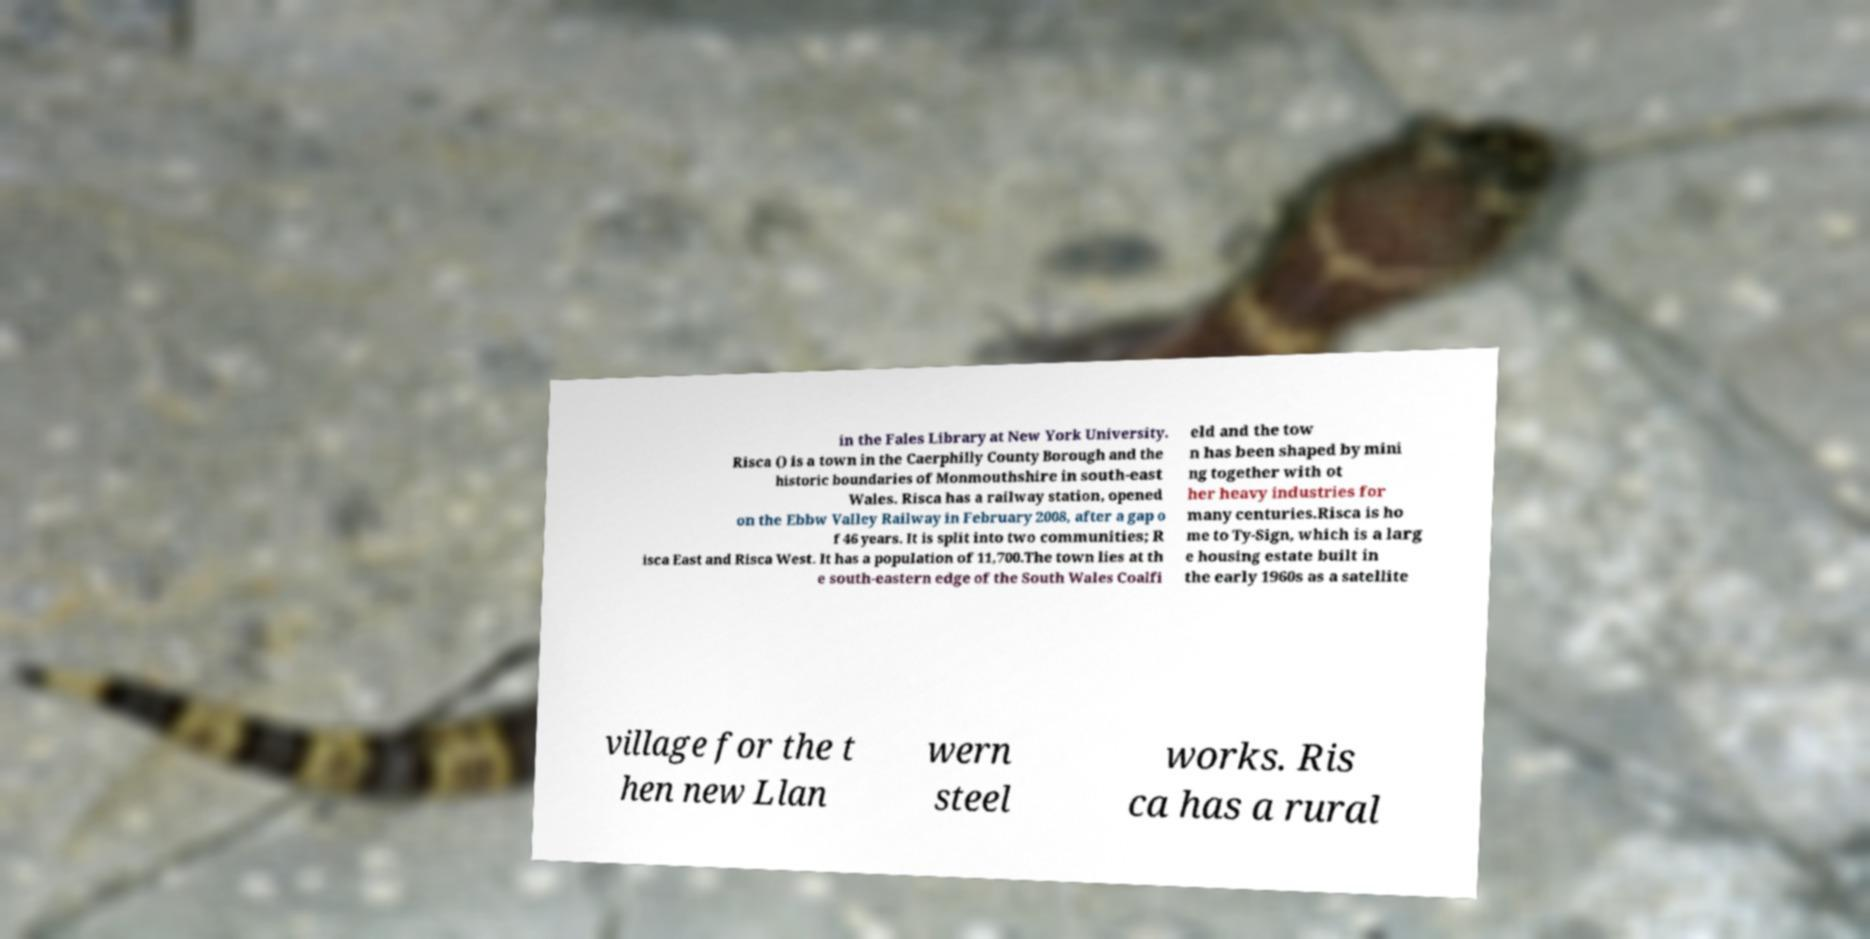There's text embedded in this image that I need extracted. Can you transcribe it verbatim? in the Fales Library at New York University. Risca () is a town in the Caerphilly County Borough and the historic boundaries of Monmouthshire in south-east Wales. Risca has a railway station, opened on the Ebbw Valley Railway in February 2008, after a gap o f 46 years. It is split into two communities; R isca East and Risca West. It has a population of 11,700.The town lies at th e south-eastern edge of the South Wales Coalfi eld and the tow n has been shaped by mini ng together with ot her heavy industries for many centuries.Risca is ho me to Ty-Sign, which is a larg e housing estate built in the early 1960s as a satellite village for the t hen new Llan wern steel works. Ris ca has a rural 